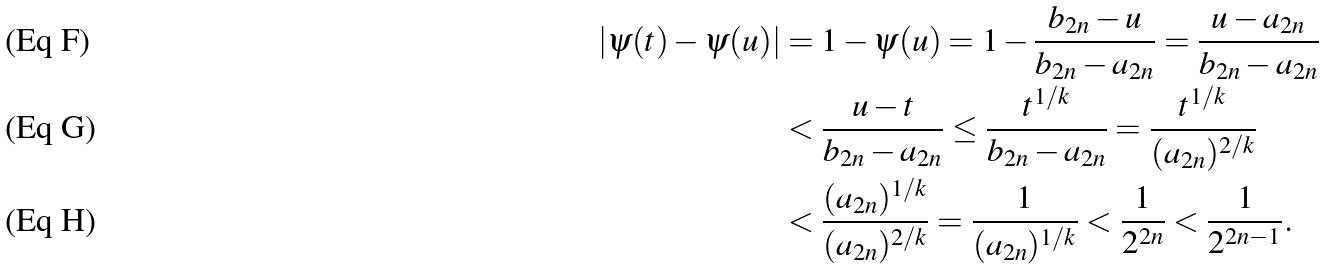Convert formula to latex. <formula><loc_0><loc_0><loc_500><loc_500>| \psi ( t ) - \psi ( u ) | & = 1 - \psi ( u ) = 1 - \frac { b _ { 2 n } - u } { b _ { 2 n } - a _ { 2 n } } = \frac { u - a _ { 2 n } } { b _ { 2 n } - a _ { 2 n } } \\ & < \frac { u - t } { b _ { 2 n } - a _ { 2 n } } \leq \frac { t ^ { 1 / k } } { b _ { 2 n } - a _ { 2 n } } = \frac { t ^ { 1 / k } } { ( a _ { 2 n } ) ^ { 2 / k } } \\ & < \frac { ( a _ { 2 n } ) ^ { 1 / k } } { ( a _ { 2 n } ) ^ { 2 / k } } = \frac { 1 } { ( a _ { 2 n } ) ^ { 1 / k } } < \frac { 1 } { 2 ^ { 2 n } } < \frac { 1 } { 2 ^ { 2 n - 1 } } .</formula> 